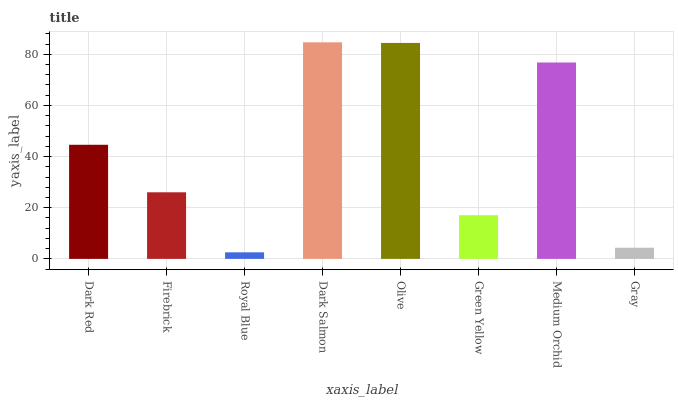Is Royal Blue the minimum?
Answer yes or no. Yes. Is Dark Salmon the maximum?
Answer yes or no. Yes. Is Firebrick the minimum?
Answer yes or no. No. Is Firebrick the maximum?
Answer yes or no. No. Is Dark Red greater than Firebrick?
Answer yes or no. Yes. Is Firebrick less than Dark Red?
Answer yes or no. Yes. Is Firebrick greater than Dark Red?
Answer yes or no. No. Is Dark Red less than Firebrick?
Answer yes or no. No. Is Dark Red the high median?
Answer yes or no. Yes. Is Firebrick the low median?
Answer yes or no. Yes. Is Royal Blue the high median?
Answer yes or no. No. Is Olive the low median?
Answer yes or no. No. 